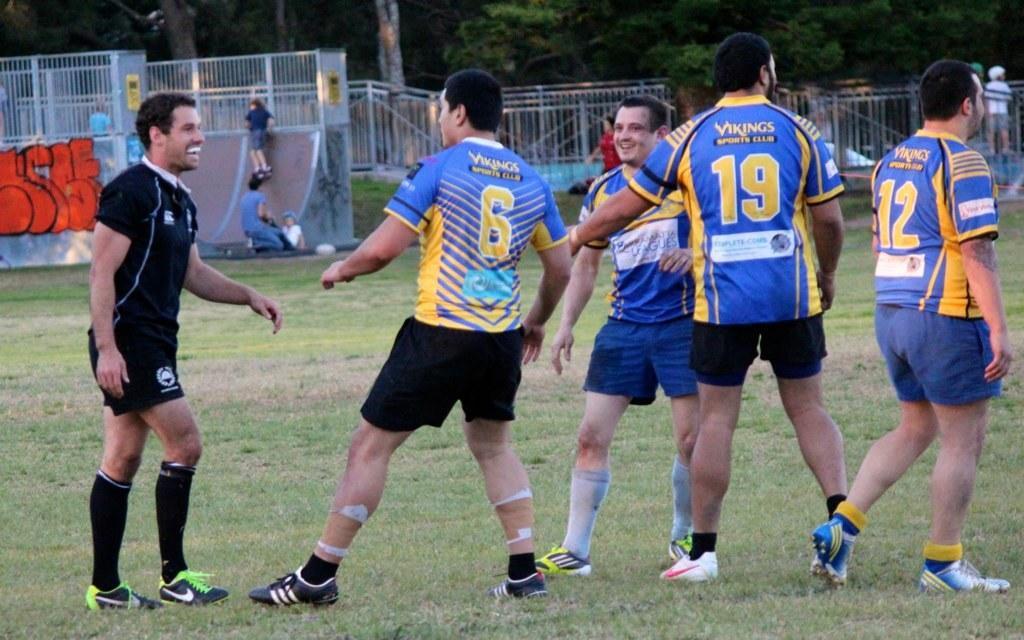Could you give a brief overview of what you see in this image? In this image we can see some trees and one ground with green grass. There are some objects on the surface, some posters and some people holding objects. 